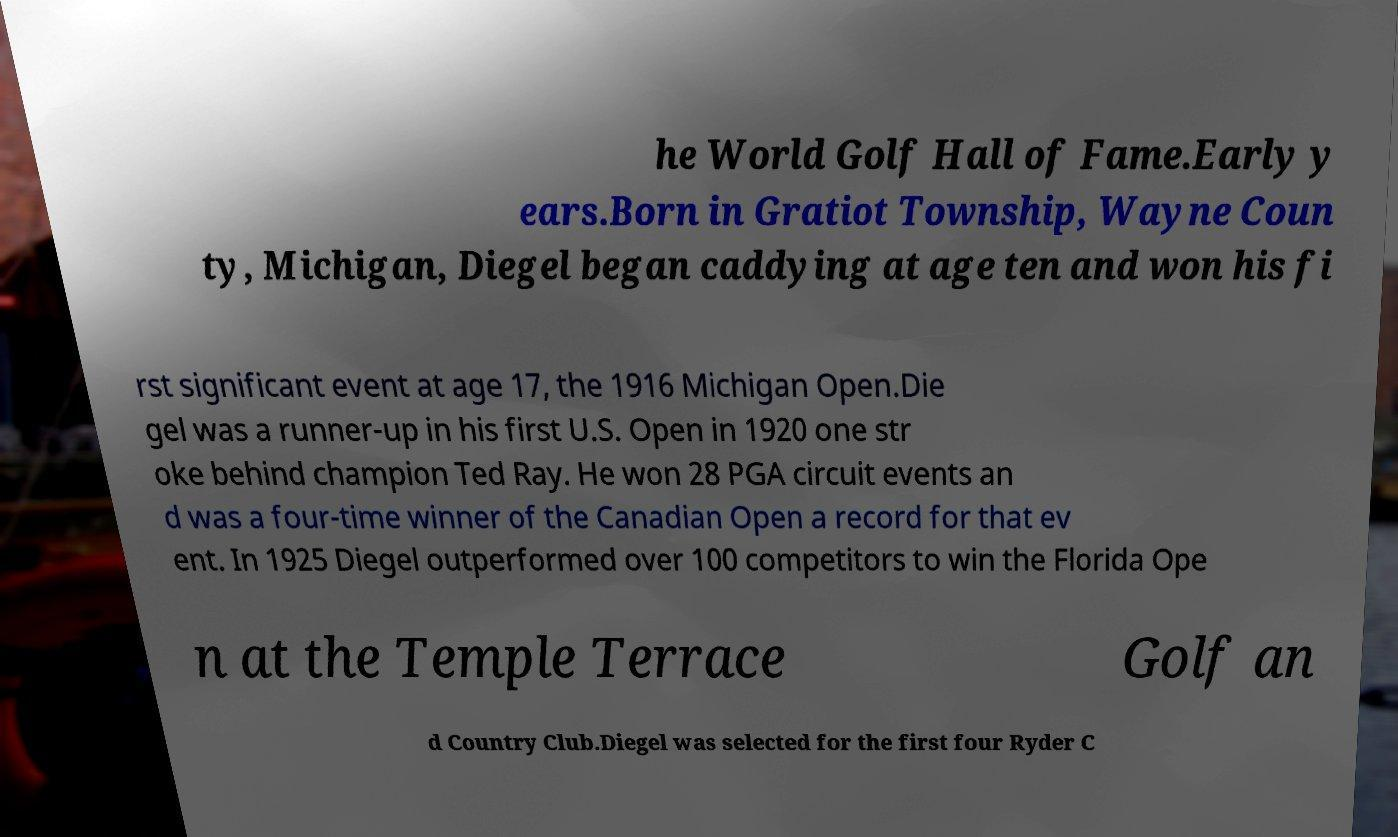Could you extract and type out the text from this image? he World Golf Hall of Fame.Early y ears.Born in Gratiot Township, Wayne Coun ty, Michigan, Diegel began caddying at age ten and won his fi rst significant event at age 17, the 1916 Michigan Open.Die gel was a runner-up in his first U.S. Open in 1920 one str oke behind champion Ted Ray. He won 28 PGA circuit events an d was a four-time winner of the Canadian Open a record for that ev ent. In 1925 Diegel outperformed over 100 competitors to win the Florida Ope n at the Temple Terrace Golf an d Country Club.Diegel was selected for the first four Ryder C 